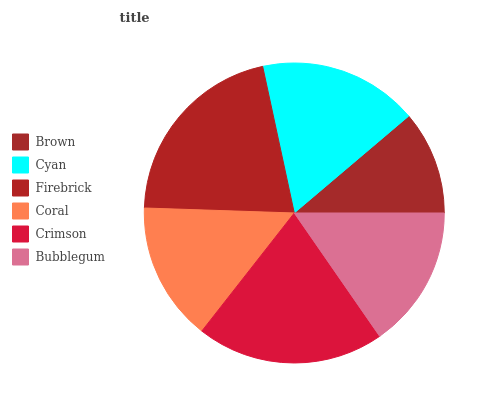Is Brown the minimum?
Answer yes or no. Yes. Is Firebrick the maximum?
Answer yes or no. Yes. Is Cyan the minimum?
Answer yes or no. No. Is Cyan the maximum?
Answer yes or no. No. Is Cyan greater than Brown?
Answer yes or no. Yes. Is Brown less than Cyan?
Answer yes or no. Yes. Is Brown greater than Cyan?
Answer yes or no. No. Is Cyan less than Brown?
Answer yes or no. No. Is Cyan the high median?
Answer yes or no. Yes. Is Bubblegum the low median?
Answer yes or no. Yes. Is Brown the high median?
Answer yes or no. No. Is Crimson the low median?
Answer yes or no. No. 